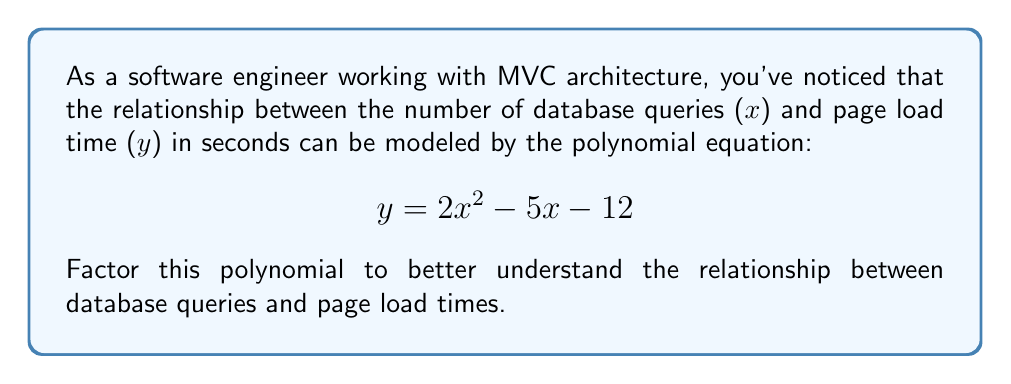Show me your answer to this math problem. To factor this polynomial, we'll follow these steps:

1) First, we recognize that this is a quadratic equation in the standard form $ax^2 + bx + c$, where:
   $a = 2$, $b = -5$, and $c = -12$

2) We'll use the ac-method (also known as grouping method) to factor this polynomial:

   a) Multiply $a * c$: $2 * (-12) = -24$
   
   b) Find two factors of -24 that add up to $b$ (-5):
      The factors are -8 and 3, because $(-8) + 3 = -5$ and $(-8) * 3 = -24$

3) Rewrite the middle term using these factors:
   $$2x^2 - 8x + 3x - 12$$

4) Group the terms:
   $$(2x^2 - 8x) + (3x - 12)$$

5) Factor out the common factor from each group:
   $$2x(x - 4) + 3(x - 4)$$

6) Factor out the common binomial $(x - 4)$:
   $$(x - 4)(2x + 3)$$

This factored form reveals that the page load time will be zero (y = 0) when $x = 4$ or $x = -\frac{3}{2}$. However, since the number of database queries can't be negative, only the $x = 4$ solution is meaningful in this context.
Answer: $$(x - 4)(2x + 3)$$ 